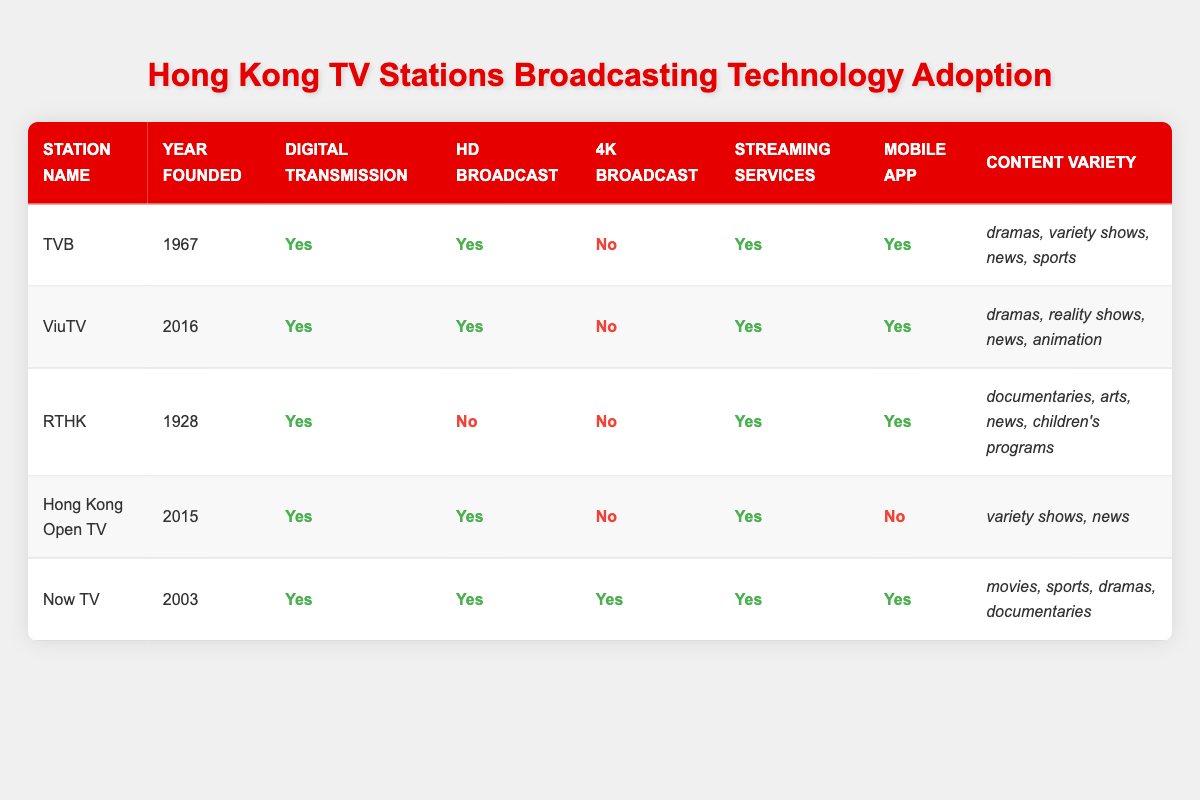What is the year of foundation for TVB? According to the table, TVB is listed with the year founded as 1967.
Answer: 1967 Which station offers 4K broadcast capabilities? Looking at the table, the only station that provides 4K broadcast is Now TV, as indicated in the relevant column.
Answer: Now TV How many stations provide digital transmission? All five stations in the table have 'Yes' under the digital transmission column, which means they all provide this capability.
Answer: 5 Which station does not have a mobile app? Referring to the table, Hong Kong Open TV is the only station without a mobile app, marked as 'No' in the respective column.
Answer: Hong Kong Open TV Are there any TV stations with HD broadcast that were founded before 2000? From the table, TVB and RTHK were both founded prior to 2000. Only TVB offers HD broadcast ('Yes'), while RTHK offers 'No', so only TVB meets the criteria.
Answer: TVB Which station has the most content variety? By examining the 'Content Variety' section, Now TV has four categories listed (movies, sports, dramas, documentaries), while other stations have fewer.
Answer: Now TV Is RTHK the only station that does not have HD or 4K broadcast capabilities? Yes, the table shows RTHK has 'No' for both HD broadcast and 4K broadcast, while others have either or both.
Answer: Yes Which stations offer streaming services? By checking the streaming services column, all five stations (TVB, ViuTV, RTHK, Hong Kong Open TV, and Now TV) offer this service as indicated by 'Yes'.
Answer: 5 Is there a station that provides HD broadcast but not 4K? Yes, TVB, ViuTV, and Hong Kong Open TV all have 'Yes' for HD and 'No' for 4K broadcast.
Answer: Yes What is the average foundation year of the TV stations in this table? Summing the years: 1967 + 2016 + 1928 + 2015 + 2003 = 10129. There are 5 stations, so average is 10129/5 = 2025.8 rounded down to 2025. The closest year foundation listed is 2016 (for ViuTV).
Answer: 2016 